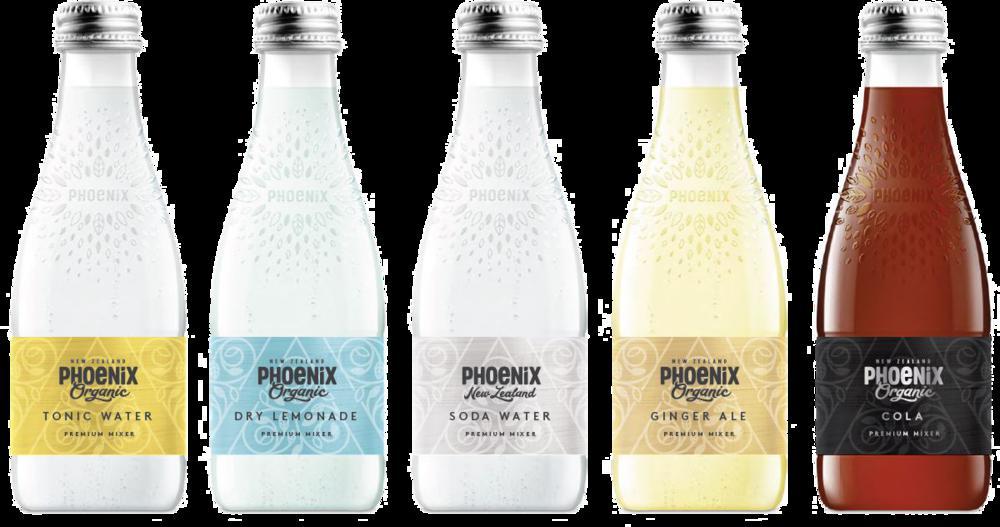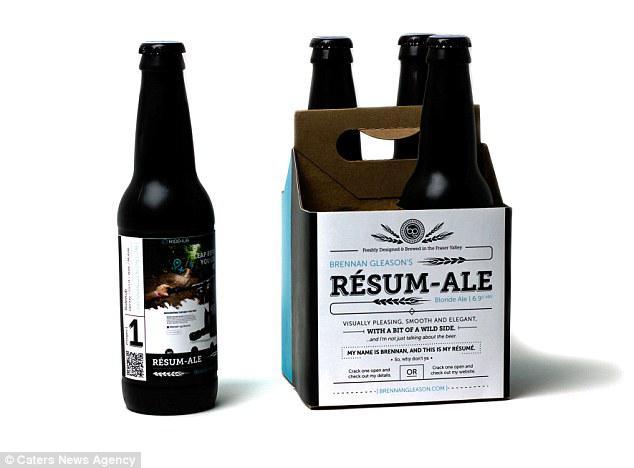The first image is the image on the left, the second image is the image on the right. For the images shown, is this caption "There are more bottles in the image on the left." true? Answer yes or no. Yes. The first image is the image on the left, the second image is the image on the right. For the images displayed, is the sentence "One image contains exactly four bottles with various colored circle shapes on each label, and the other image contains no more than four bottles with colorful imagery on their labels." factually correct? Answer yes or no. No. 